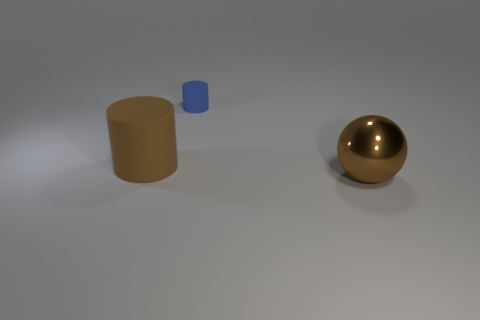How big is the thing that is behind the big ball and right of the brown rubber thing?
Keep it short and to the point. Small. What number of other objects are the same color as the ball?
Make the answer very short. 1. Do the big brown thing in front of the large brown matte cylinder and the small cylinder have the same material?
Your response must be concise. No. Are there any other things that are the same size as the blue cylinder?
Provide a short and direct response. No. Are there fewer tiny matte cylinders that are in front of the big rubber object than big brown things that are right of the small blue cylinder?
Make the answer very short. Yes. Are there any other things that are the same shape as the large brown metal object?
Provide a succinct answer. No. There is a big ball that is the same color as the big matte cylinder; what is its material?
Give a very brief answer. Metal. How many large brown matte cylinders are in front of the large object that is on the right side of the brown thing that is left of the brown shiny ball?
Offer a terse response. 0. There is a tiny blue cylinder; what number of small rubber objects are behind it?
Offer a terse response. 0. How many other spheres are made of the same material as the sphere?
Provide a succinct answer. 0. 